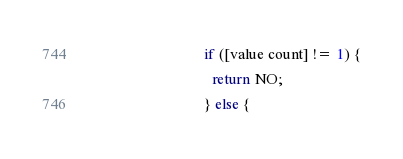Convert code to text. <code><loc_0><loc_0><loc_500><loc_500><_ObjectiveC_>                               if ([value count] != 1) {
                                 return NO;
                               } else {</code> 